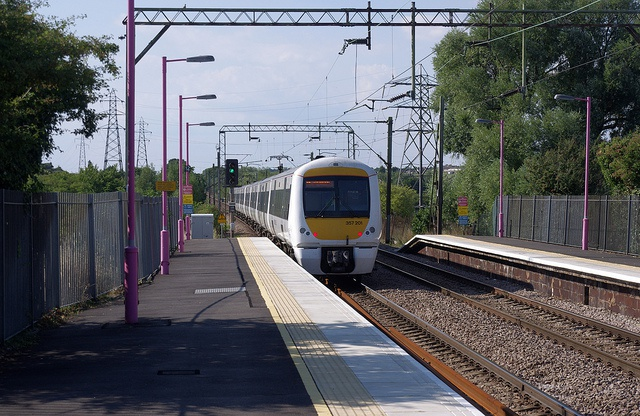Describe the objects in this image and their specific colors. I can see train in black, gray, olive, and darkgray tones and traffic light in black, gray, darkgreen, and teal tones in this image. 